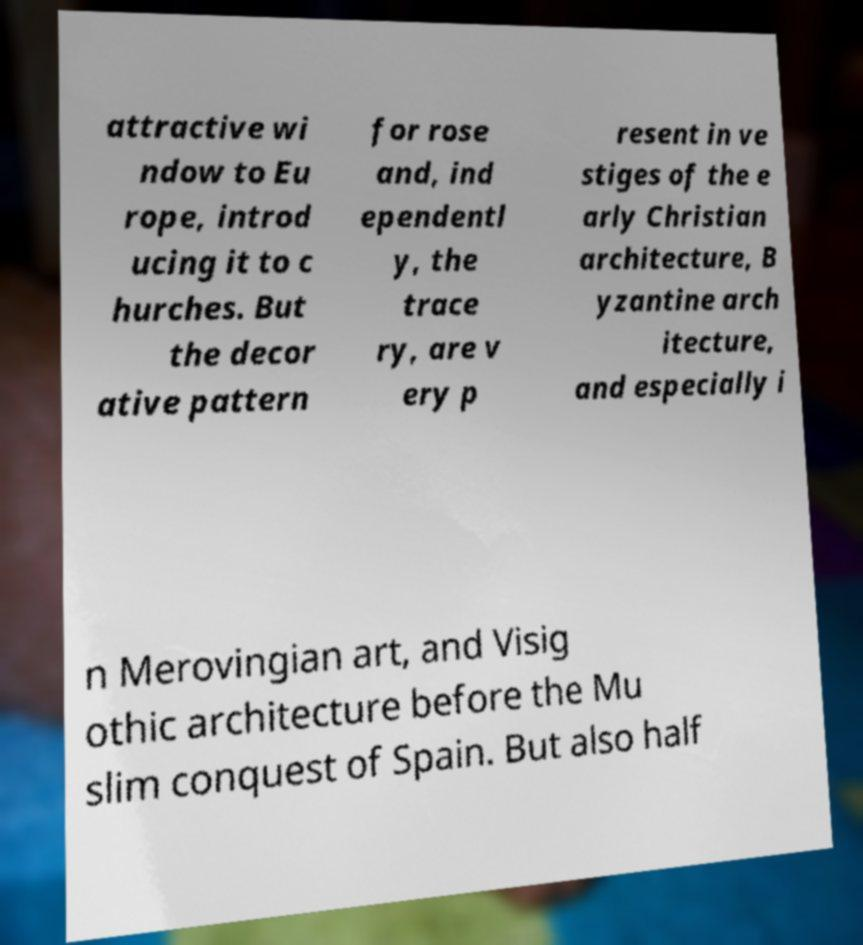Please identify and transcribe the text found in this image. attractive wi ndow to Eu rope, introd ucing it to c hurches. But the decor ative pattern for rose and, ind ependentl y, the trace ry, are v ery p resent in ve stiges of the e arly Christian architecture, B yzantine arch itecture, and especially i n Merovingian art, and Visig othic architecture before the Mu slim conquest of Spain. But also half 